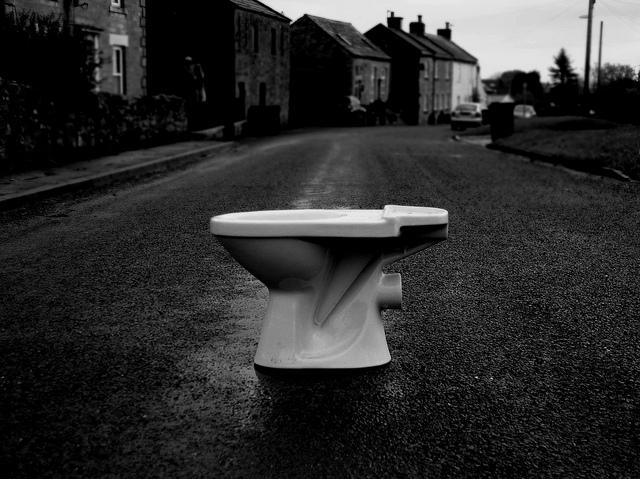Has the toilet been painted?
Concise answer only. No. What is in the middle of the road?
Write a very short answer. Toilet. What type of zone is this toilet parked in?
Quick response, please. Road. What is the toilet sitting on?
Answer briefly. Street. 